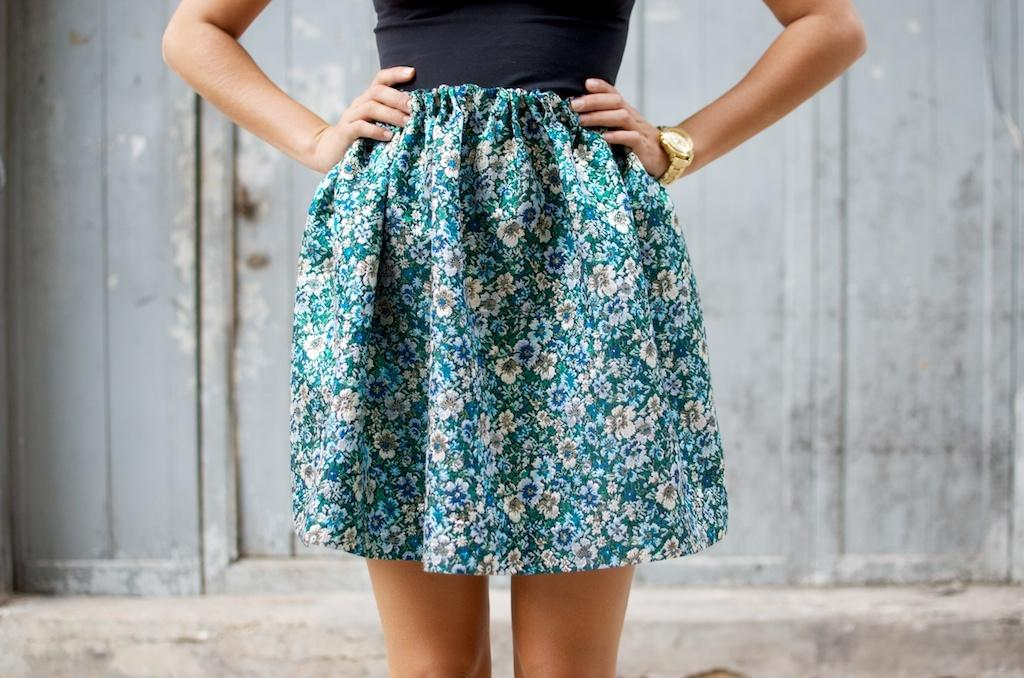What is the main subject of the image? There is a lady standing in the center of the image. What is the lady wearing? The lady is wearing a skirt. What can be seen in the background of the image? There is a wall in the background of the image. What type of glass is the lady holding in the image? There is no glass present in the image; the lady is not holding anything. 